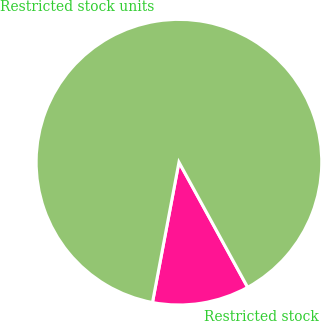<chart> <loc_0><loc_0><loc_500><loc_500><pie_chart><fcel>Restricted stock<fcel>Restricted stock units<nl><fcel>10.96%<fcel>89.04%<nl></chart> 